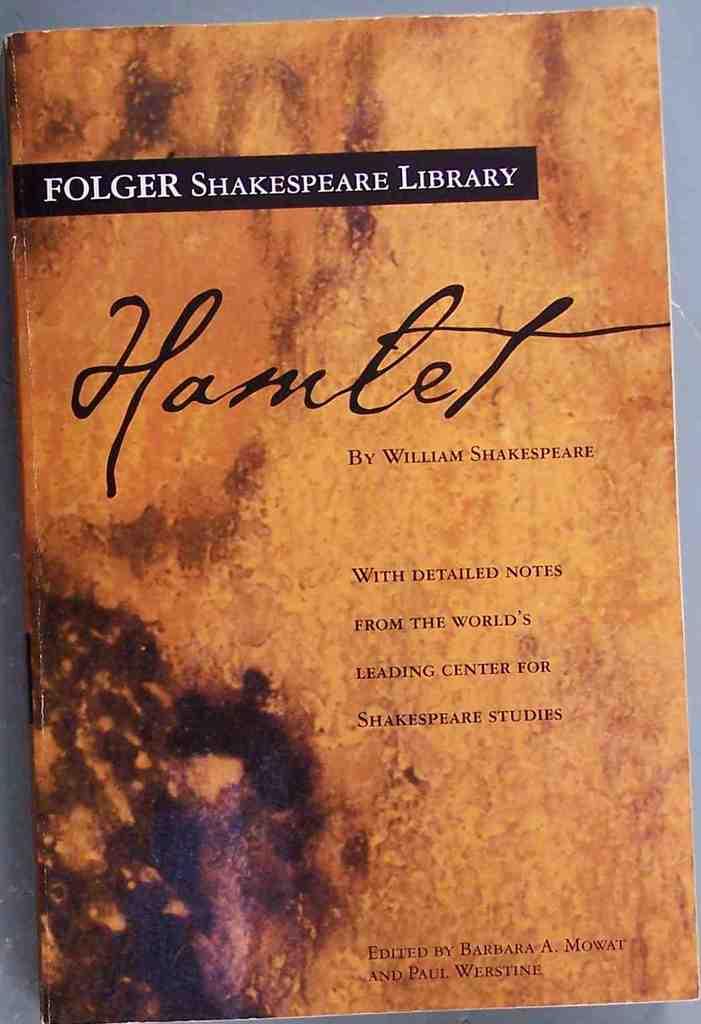What is the title of this work?
Your answer should be compact. Hamlet. 